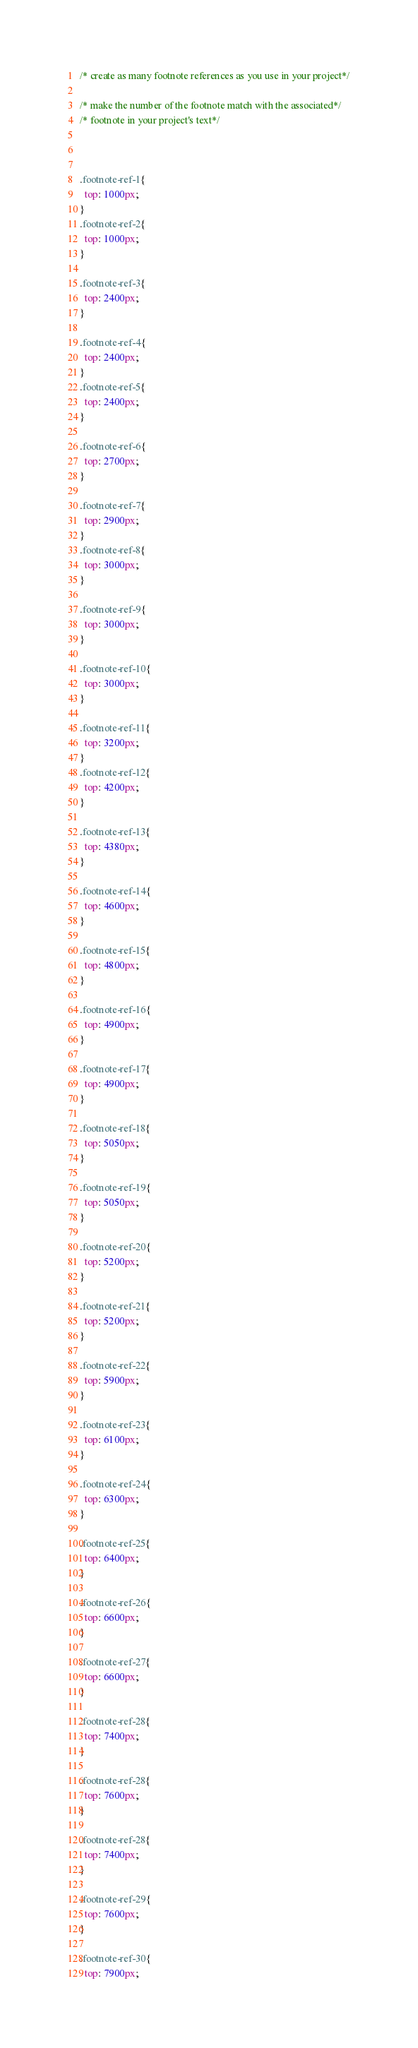<code> <loc_0><loc_0><loc_500><loc_500><_CSS_>
/* create as many footnote references as you use in your project*/

/* make the number of the footnote match with the associated*/
/* footnote in your project's text*/



.footnote-ref-1{
  top: 1000px;
}
.footnote-ref-2{
  top: 1000px;
}

.footnote-ref-3{
  top: 2400px;
}

.footnote-ref-4{
  top: 2400px;
}
.footnote-ref-5{
  top: 2400px;
}

.footnote-ref-6{
  top: 2700px;
}

.footnote-ref-7{
  top: 2900px;
}
.footnote-ref-8{
  top: 3000px;
}

.footnote-ref-9{
  top: 3000px;
}

.footnote-ref-10{
  top: 3000px;
}

.footnote-ref-11{
  top: 3200px;
}
.footnote-ref-12{
  top: 4200px;
}

.footnote-ref-13{
  top: 4380px;
}

.footnote-ref-14{
  top: 4600px;
}

.footnote-ref-15{
  top: 4800px;
}

.footnote-ref-16{
  top: 4900px;
}

.footnote-ref-17{
  top: 4900px;
}

.footnote-ref-18{
  top: 5050px;
}

.footnote-ref-19{
  top: 5050px;
}

.footnote-ref-20{
  top: 5200px;
}

.footnote-ref-21{
  top: 5200px;
}

.footnote-ref-22{
  top: 5900px;
}

.footnote-ref-23{
  top: 6100px;
}

.footnote-ref-24{
  top: 6300px;
}

.footnote-ref-25{
  top: 6400px;
}

.footnote-ref-26{
  top: 6600px;
}

.footnote-ref-27{
  top: 6600px;
}

.footnote-ref-28{
  top: 7400px;
}

.footnote-ref-28{
  top: 7600px;
}

.footnote-ref-28{
  top: 7400px;
}

.footnote-ref-29{
  top: 7600px;
}

.footnote-ref-30{
  top: 7900px;
</code> 